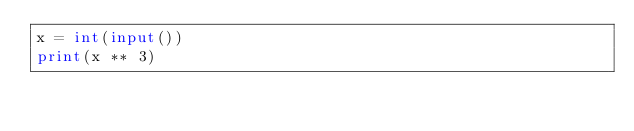<code> <loc_0><loc_0><loc_500><loc_500><_Python_>x = int(input())
print(x ** 3)
</code> 